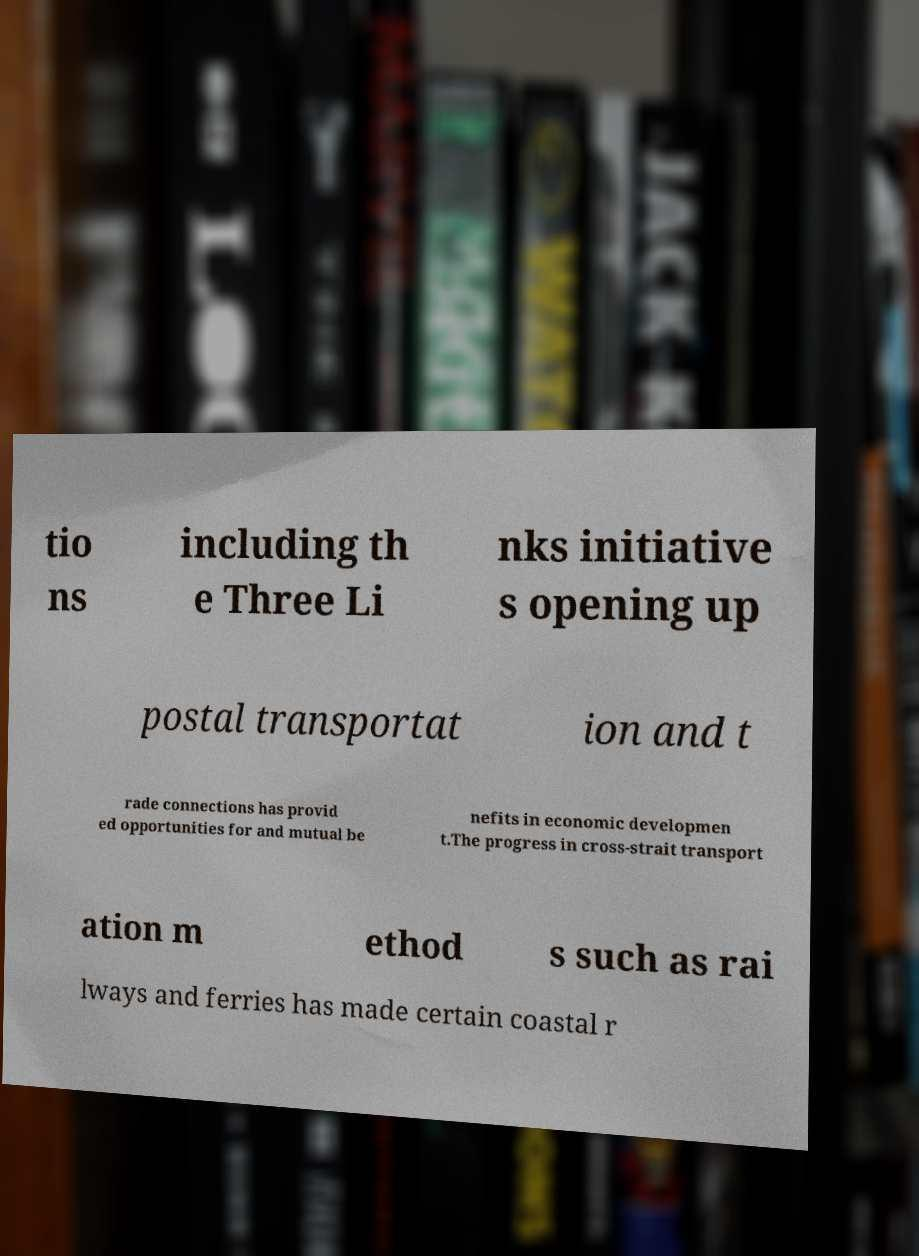Please read and relay the text visible in this image. What does it say? tio ns including th e Three Li nks initiative s opening up postal transportat ion and t rade connections has provid ed opportunities for and mutual be nefits in economic developmen t.The progress in cross-strait transport ation m ethod s such as rai lways and ferries has made certain coastal r 